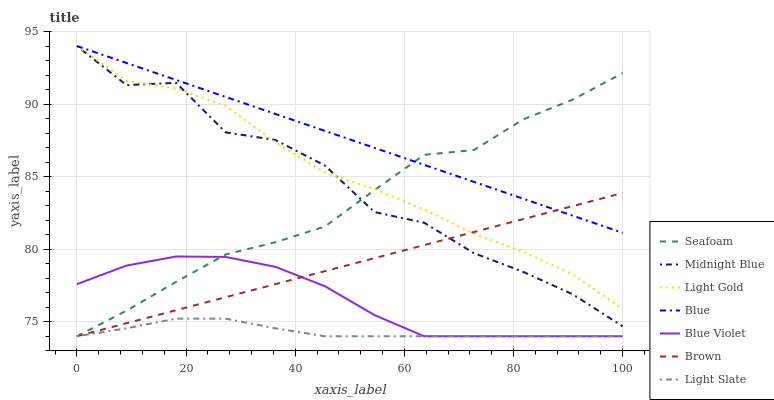Does Brown have the minimum area under the curve?
Answer yes or no. No. Does Brown have the maximum area under the curve?
Answer yes or no. No. Is Midnight Blue the smoothest?
Answer yes or no. No. Is Brown the roughest?
Answer yes or no. No. Does Midnight Blue have the lowest value?
Answer yes or no. No. Does Brown have the highest value?
Answer yes or no. No. Is Light Slate less than Light Gold?
Answer yes or no. Yes. Is Midnight Blue greater than Light Slate?
Answer yes or no. Yes. Does Light Slate intersect Light Gold?
Answer yes or no. No. 